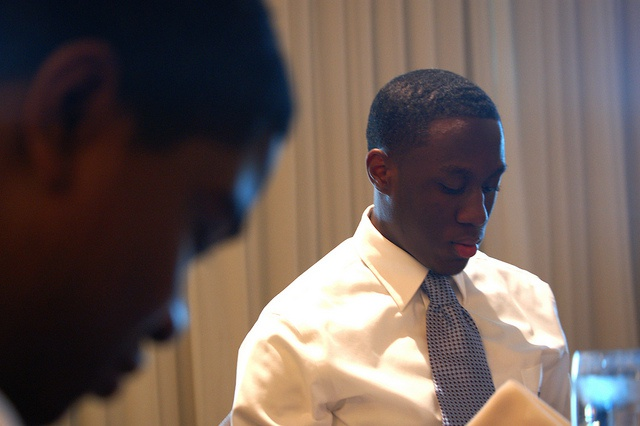Describe the objects in this image and their specific colors. I can see people in black, gray, and darkblue tones, people in black, ivory, gray, and tan tones, tie in black and gray tones, cup in black, lightblue, and gray tones, and book in black and tan tones in this image. 